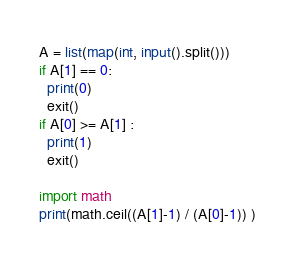<code> <loc_0><loc_0><loc_500><loc_500><_Python_>A = list(map(int, input().split()))
if A[1] == 0:
  print(0)
  exit()
if A[0] >= A[1] :
  print(1)
  exit()
  
import math  
print(math.ceil((A[1]-1) / (A[0]-1)) ) </code> 